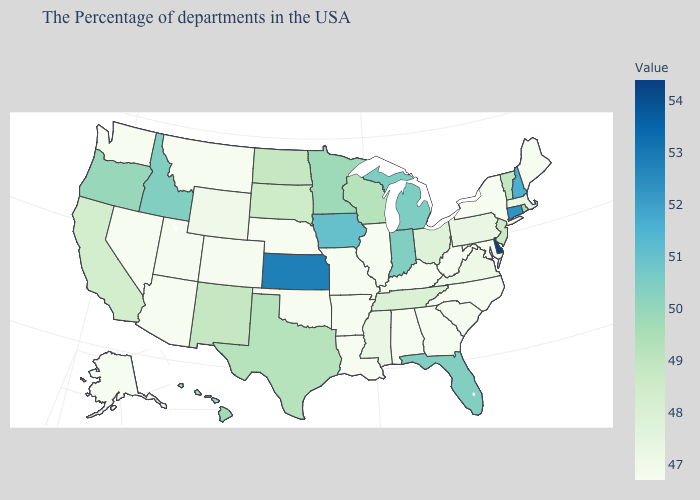Does Nevada have the lowest value in the West?
Concise answer only. Yes. Does Florida have a higher value than Pennsylvania?
Short answer required. Yes. Among the states that border Vermont , which have the lowest value?
Quick response, please. New York. Is the legend a continuous bar?
Write a very short answer. Yes. Does the map have missing data?
Short answer required. No. Does Iowa have the lowest value in the USA?
Short answer required. No. Among the states that border Illinois , does Missouri have the highest value?
Be succinct. No. Which states have the highest value in the USA?
Short answer required. Delaware. Does Montana have a lower value than Vermont?
Quick response, please. Yes. 